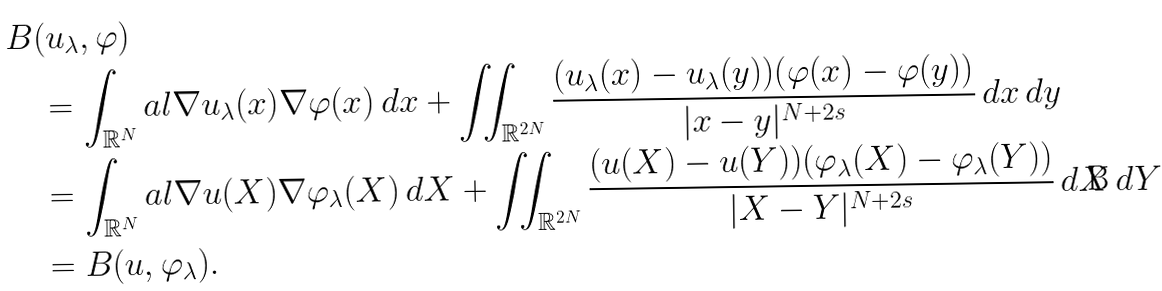Convert formula to latex. <formula><loc_0><loc_0><loc_500><loc_500>& B ( u _ { \lambda } , \varphi ) \\ & \quad = \int _ { \mathbb { R } ^ { N } } a l { \nabla u _ { \lambda } ( x ) } { \nabla \varphi ( x ) } \, d x + \iint _ { \mathbb { R } ^ { 2 N } } \frac { ( u _ { \lambda } ( x ) - u _ { \lambda } ( y ) ) ( \varphi ( x ) - \varphi ( y ) ) } { | x - y | ^ { N + 2 s } } \, d x \, d y \\ & \quad = \int _ { \mathbb { R } ^ { N } } a l { \nabla u ( X ) } { \nabla \varphi _ { \lambda } ( X ) } \, d X + \iint _ { \mathbb { R } ^ { 2 N } } \frac { ( u ( X ) - u ( Y ) ) ( \varphi _ { \lambda } ( X ) - \varphi _ { \lambda } ( Y ) ) } { | X - Y | ^ { N + 2 s } } \, d X \, d Y \\ & \quad = B ( u , \varphi _ { \lambda } ) .</formula> 